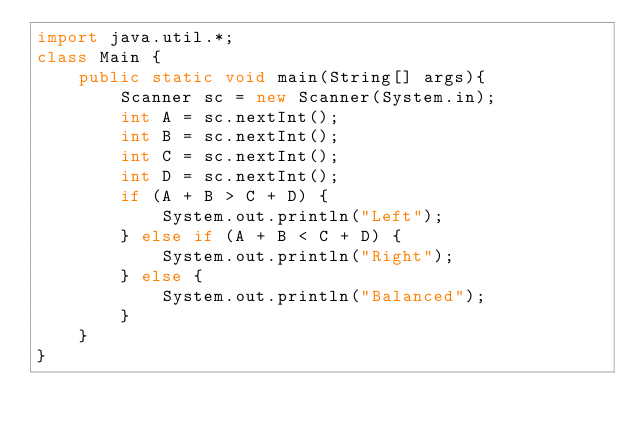Convert code to text. <code><loc_0><loc_0><loc_500><loc_500><_Java_>import java.util.*;
class Main {
	public static void main(String[] args){
		Scanner sc = new Scanner(System.in);
		int A = sc.nextInt();
		int B = sc.nextInt();
		int C = sc.nextInt();
		int D = sc.nextInt();
		if (A + B > C + D) {
			System.out.println("Left");
		} else if (A + B < C + D) {
			System.out.println("Right");
		} else {
			System.out.println("Balanced");
		}
	}
}</code> 